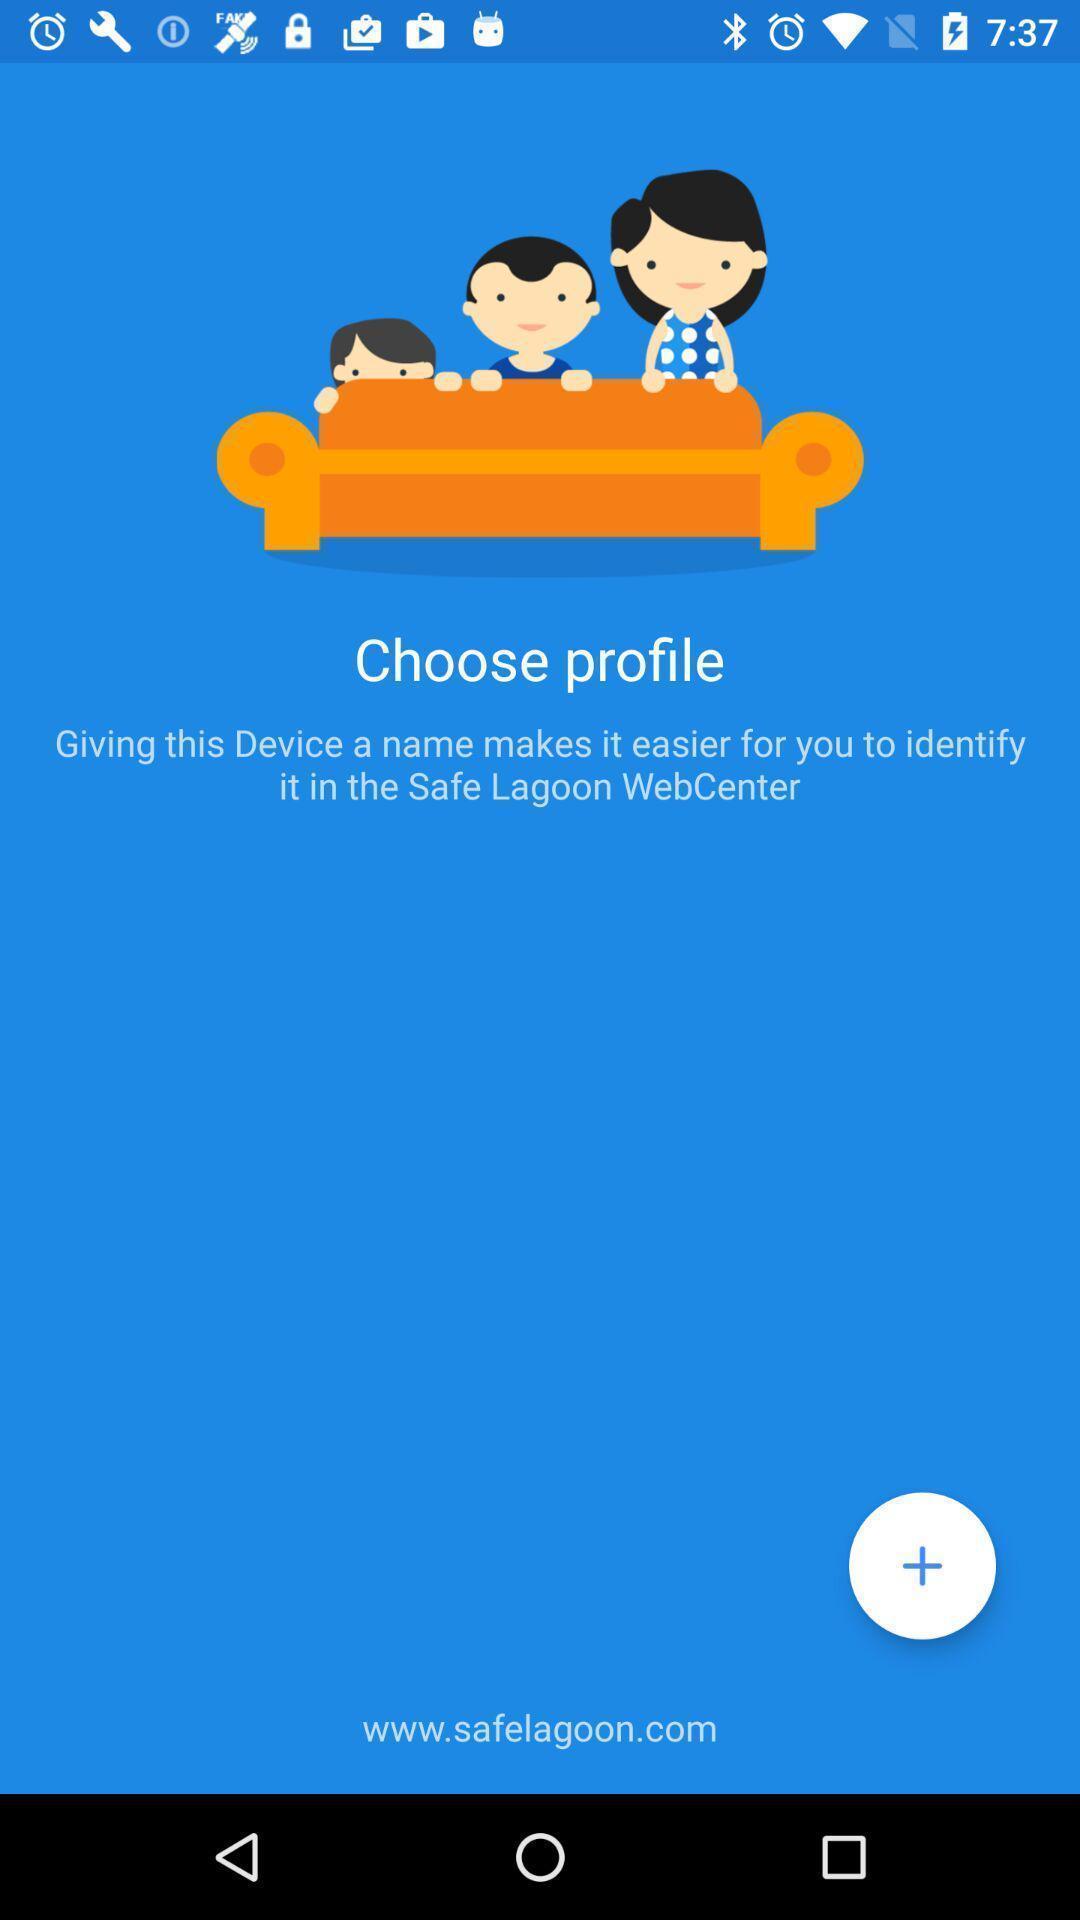Give me a narrative description of this picture. Welcome page of a online family protection app. 